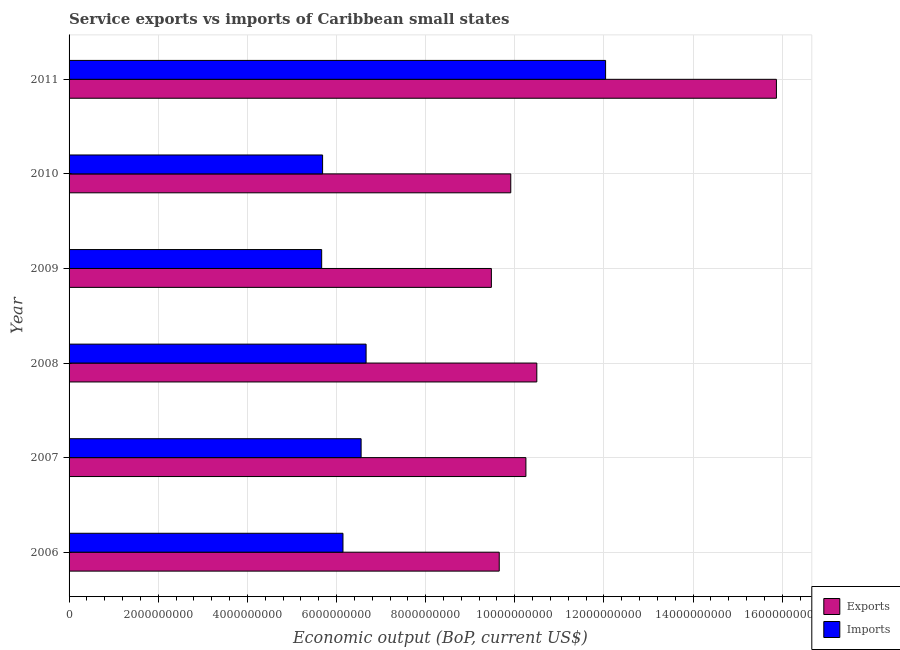How many bars are there on the 6th tick from the bottom?
Provide a succinct answer. 2. What is the label of the 3rd group of bars from the top?
Give a very brief answer. 2009. What is the amount of service imports in 2011?
Offer a very short reply. 1.20e+1. Across all years, what is the maximum amount of service imports?
Provide a succinct answer. 1.20e+1. Across all years, what is the minimum amount of service exports?
Give a very brief answer. 9.47e+09. What is the total amount of service exports in the graph?
Give a very brief answer. 6.56e+1. What is the difference between the amount of service exports in 2006 and that in 2008?
Keep it short and to the point. -8.43e+08. What is the difference between the amount of service exports in 2009 and the amount of service imports in 2007?
Ensure brevity in your answer.  2.92e+09. What is the average amount of service exports per year?
Provide a succinct answer. 1.09e+1. In the year 2006, what is the difference between the amount of service exports and amount of service imports?
Offer a very short reply. 3.51e+09. What is the ratio of the amount of service exports in 2009 to that in 2010?
Give a very brief answer. 0.96. Is the amount of service exports in 2010 less than that in 2011?
Your answer should be very brief. Yes. What is the difference between the highest and the second highest amount of service imports?
Keep it short and to the point. 5.37e+09. What is the difference between the highest and the lowest amount of service exports?
Your answer should be compact. 6.39e+09. In how many years, is the amount of service exports greater than the average amount of service exports taken over all years?
Your answer should be compact. 1. What does the 1st bar from the top in 2008 represents?
Offer a very short reply. Imports. What does the 1st bar from the bottom in 2010 represents?
Provide a short and direct response. Exports. Are all the bars in the graph horizontal?
Give a very brief answer. Yes. What is the difference between two consecutive major ticks on the X-axis?
Your response must be concise. 2.00e+09. Does the graph contain any zero values?
Keep it short and to the point. No. Does the graph contain grids?
Provide a succinct answer. Yes. How many legend labels are there?
Your response must be concise. 2. How are the legend labels stacked?
Your response must be concise. Vertical. What is the title of the graph?
Give a very brief answer. Service exports vs imports of Caribbean small states. Does "Agricultural land" appear as one of the legend labels in the graph?
Your answer should be compact. No. What is the label or title of the X-axis?
Keep it short and to the point. Economic output (BoP, current US$). What is the label or title of the Y-axis?
Offer a very short reply. Year. What is the Economic output (BoP, current US$) of Exports in 2006?
Give a very brief answer. 9.65e+09. What is the Economic output (BoP, current US$) in Imports in 2006?
Make the answer very short. 6.14e+09. What is the Economic output (BoP, current US$) in Exports in 2007?
Ensure brevity in your answer.  1.02e+1. What is the Economic output (BoP, current US$) of Imports in 2007?
Offer a terse response. 6.55e+09. What is the Economic output (BoP, current US$) of Exports in 2008?
Provide a succinct answer. 1.05e+1. What is the Economic output (BoP, current US$) of Imports in 2008?
Provide a succinct answer. 6.66e+09. What is the Economic output (BoP, current US$) of Exports in 2009?
Offer a terse response. 9.47e+09. What is the Economic output (BoP, current US$) in Imports in 2009?
Your answer should be compact. 5.67e+09. What is the Economic output (BoP, current US$) in Exports in 2010?
Provide a succinct answer. 9.91e+09. What is the Economic output (BoP, current US$) of Imports in 2010?
Your answer should be compact. 5.69e+09. What is the Economic output (BoP, current US$) in Exports in 2011?
Keep it short and to the point. 1.59e+1. What is the Economic output (BoP, current US$) in Imports in 2011?
Your answer should be compact. 1.20e+1. Across all years, what is the maximum Economic output (BoP, current US$) of Exports?
Offer a terse response. 1.59e+1. Across all years, what is the maximum Economic output (BoP, current US$) of Imports?
Offer a very short reply. 1.20e+1. Across all years, what is the minimum Economic output (BoP, current US$) of Exports?
Offer a very short reply. 9.47e+09. Across all years, what is the minimum Economic output (BoP, current US$) of Imports?
Your response must be concise. 5.67e+09. What is the total Economic output (BoP, current US$) of Exports in the graph?
Provide a succinct answer. 6.56e+1. What is the total Economic output (BoP, current US$) of Imports in the graph?
Keep it short and to the point. 4.28e+1. What is the difference between the Economic output (BoP, current US$) of Exports in 2006 and that in 2007?
Provide a short and direct response. -5.98e+08. What is the difference between the Economic output (BoP, current US$) of Imports in 2006 and that in 2007?
Your response must be concise. -4.07e+08. What is the difference between the Economic output (BoP, current US$) in Exports in 2006 and that in 2008?
Offer a terse response. -8.43e+08. What is the difference between the Economic output (BoP, current US$) in Imports in 2006 and that in 2008?
Provide a succinct answer. -5.19e+08. What is the difference between the Economic output (BoP, current US$) in Exports in 2006 and that in 2009?
Provide a short and direct response. 1.76e+08. What is the difference between the Economic output (BoP, current US$) of Imports in 2006 and that in 2009?
Make the answer very short. 4.78e+08. What is the difference between the Economic output (BoP, current US$) in Exports in 2006 and that in 2010?
Give a very brief answer. -2.59e+08. What is the difference between the Economic output (BoP, current US$) in Imports in 2006 and that in 2010?
Keep it short and to the point. 4.57e+08. What is the difference between the Economic output (BoP, current US$) in Exports in 2006 and that in 2011?
Provide a short and direct response. -6.22e+09. What is the difference between the Economic output (BoP, current US$) of Imports in 2006 and that in 2011?
Your answer should be compact. -5.89e+09. What is the difference between the Economic output (BoP, current US$) in Exports in 2007 and that in 2008?
Offer a very short reply. -2.45e+08. What is the difference between the Economic output (BoP, current US$) of Imports in 2007 and that in 2008?
Your response must be concise. -1.12e+08. What is the difference between the Economic output (BoP, current US$) of Exports in 2007 and that in 2009?
Give a very brief answer. 7.75e+08. What is the difference between the Economic output (BoP, current US$) in Imports in 2007 and that in 2009?
Offer a terse response. 8.85e+08. What is the difference between the Economic output (BoP, current US$) in Exports in 2007 and that in 2010?
Keep it short and to the point. 3.39e+08. What is the difference between the Economic output (BoP, current US$) in Imports in 2007 and that in 2010?
Provide a short and direct response. 8.64e+08. What is the difference between the Economic output (BoP, current US$) of Exports in 2007 and that in 2011?
Provide a short and direct response. -5.62e+09. What is the difference between the Economic output (BoP, current US$) of Imports in 2007 and that in 2011?
Ensure brevity in your answer.  -5.48e+09. What is the difference between the Economic output (BoP, current US$) in Exports in 2008 and that in 2009?
Your answer should be very brief. 1.02e+09. What is the difference between the Economic output (BoP, current US$) in Imports in 2008 and that in 2009?
Your answer should be very brief. 9.96e+08. What is the difference between the Economic output (BoP, current US$) in Exports in 2008 and that in 2010?
Provide a short and direct response. 5.84e+08. What is the difference between the Economic output (BoP, current US$) of Imports in 2008 and that in 2010?
Offer a terse response. 9.76e+08. What is the difference between the Economic output (BoP, current US$) of Exports in 2008 and that in 2011?
Ensure brevity in your answer.  -5.38e+09. What is the difference between the Economic output (BoP, current US$) of Imports in 2008 and that in 2011?
Provide a succinct answer. -5.37e+09. What is the difference between the Economic output (BoP, current US$) of Exports in 2009 and that in 2010?
Make the answer very short. -4.35e+08. What is the difference between the Economic output (BoP, current US$) of Imports in 2009 and that in 2010?
Offer a very short reply. -2.06e+07. What is the difference between the Economic output (BoP, current US$) in Exports in 2009 and that in 2011?
Provide a short and direct response. -6.39e+09. What is the difference between the Economic output (BoP, current US$) of Imports in 2009 and that in 2011?
Your answer should be very brief. -6.37e+09. What is the difference between the Economic output (BoP, current US$) of Exports in 2010 and that in 2011?
Keep it short and to the point. -5.96e+09. What is the difference between the Economic output (BoP, current US$) in Imports in 2010 and that in 2011?
Give a very brief answer. -6.35e+09. What is the difference between the Economic output (BoP, current US$) of Exports in 2006 and the Economic output (BoP, current US$) of Imports in 2007?
Give a very brief answer. 3.10e+09. What is the difference between the Economic output (BoP, current US$) of Exports in 2006 and the Economic output (BoP, current US$) of Imports in 2008?
Provide a succinct answer. 2.99e+09. What is the difference between the Economic output (BoP, current US$) in Exports in 2006 and the Economic output (BoP, current US$) in Imports in 2009?
Your answer should be very brief. 3.98e+09. What is the difference between the Economic output (BoP, current US$) of Exports in 2006 and the Economic output (BoP, current US$) of Imports in 2010?
Your answer should be compact. 3.96e+09. What is the difference between the Economic output (BoP, current US$) in Exports in 2006 and the Economic output (BoP, current US$) in Imports in 2011?
Offer a terse response. -2.39e+09. What is the difference between the Economic output (BoP, current US$) of Exports in 2007 and the Economic output (BoP, current US$) of Imports in 2008?
Provide a succinct answer. 3.59e+09. What is the difference between the Economic output (BoP, current US$) of Exports in 2007 and the Economic output (BoP, current US$) of Imports in 2009?
Your answer should be very brief. 4.58e+09. What is the difference between the Economic output (BoP, current US$) in Exports in 2007 and the Economic output (BoP, current US$) in Imports in 2010?
Provide a short and direct response. 4.56e+09. What is the difference between the Economic output (BoP, current US$) in Exports in 2007 and the Economic output (BoP, current US$) in Imports in 2011?
Your answer should be very brief. -1.79e+09. What is the difference between the Economic output (BoP, current US$) of Exports in 2008 and the Economic output (BoP, current US$) of Imports in 2009?
Your response must be concise. 4.83e+09. What is the difference between the Economic output (BoP, current US$) in Exports in 2008 and the Economic output (BoP, current US$) in Imports in 2010?
Provide a short and direct response. 4.81e+09. What is the difference between the Economic output (BoP, current US$) of Exports in 2008 and the Economic output (BoP, current US$) of Imports in 2011?
Your answer should be compact. -1.54e+09. What is the difference between the Economic output (BoP, current US$) in Exports in 2009 and the Economic output (BoP, current US$) in Imports in 2010?
Give a very brief answer. 3.79e+09. What is the difference between the Economic output (BoP, current US$) in Exports in 2009 and the Economic output (BoP, current US$) in Imports in 2011?
Your answer should be very brief. -2.56e+09. What is the difference between the Economic output (BoP, current US$) in Exports in 2010 and the Economic output (BoP, current US$) in Imports in 2011?
Give a very brief answer. -2.13e+09. What is the average Economic output (BoP, current US$) in Exports per year?
Offer a very short reply. 1.09e+1. What is the average Economic output (BoP, current US$) in Imports per year?
Your answer should be very brief. 7.13e+09. In the year 2006, what is the difference between the Economic output (BoP, current US$) in Exports and Economic output (BoP, current US$) in Imports?
Your response must be concise. 3.51e+09. In the year 2007, what is the difference between the Economic output (BoP, current US$) of Exports and Economic output (BoP, current US$) of Imports?
Offer a very short reply. 3.70e+09. In the year 2008, what is the difference between the Economic output (BoP, current US$) of Exports and Economic output (BoP, current US$) of Imports?
Ensure brevity in your answer.  3.83e+09. In the year 2009, what is the difference between the Economic output (BoP, current US$) of Exports and Economic output (BoP, current US$) of Imports?
Your answer should be compact. 3.81e+09. In the year 2010, what is the difference between the Economic output (BoP, current US$) of Exports and Economic output (BoP, current US$) of Imports?
Offer a very short reply. 4.22e+09. In the year 2011, what is the difference between the Economic output (BoP, current US$) of Exports and Economic output (BoP, current US$) of Imports?
Offer a very short reply. 3.83e+09. What is the ratio of the Economic output (BoP, current US$) of Exports in 2006 to that in 2007?
Provide a short and direct response. 0.94. What is the ratio of the Economic output (BoP, current US$) in Imports in 2006 to that in 2007?
Ensure brevity in your answer.  0.94. What is the ratio of the Economic output (BoP, current US$) in Exports in 2006 to that in 2008?
Offer a terse response. 0.92. What is the ratio of the Economic output (BoP, current US$) of Imports in 2006 to that in 2008?
Offer a very short reply. 0.92. What is the ratio of the Economic output (BoP, current US$) in Exports in 2006 to that in 2009?
Give a very brief answer. 1.02. What is the ratio of the Economic output (BoP, current US$) in Imports in 2006 to that in 2009?
Ensure brevity in your answer.  1.08. What is the ratio of the Economic output (BoP, current US$) in Exports in 2006 to that in 2010?
Give a very brief answer. 0.97. What is the ratio of the Economic output (BoP, current US$) of Imports in 2006 to that in 2010?
Offer a very short reply. 1.08. What is the ratio of the Economic output (BoP, current US$) of Exports in 2006 to that in 2011?
Provide a succinct answer. 0.61. What is the ratio of the Economic output (BoP, current US$) in Imports in 2006 to that in 2011?
Provide a succinct answer. 0.51. What is the ratio of the Economic output (BoP, current US$) of Exports in 2007 to that in 2008?
Give a very brief answer. 0.98. What is the ratio of the Economic output (BoP, current US$) in Imports in 2007 to that in 2008?
Your response must be concise. 0.98. What is the ratio of the Economic output (BoP, current US$) of Exports in 2007 to that in 2009?
Your answer should be very brief. 1.08. What is the ratio of the Economic output (BoP, current US$) in Imports in 2007 to that in 2009?
Provide a short and direct response. 1.16. What is the ratio of the Economic output (BoP, current US$) in Exports in 2007 to that in 2010?
Keep it short and to the point. 1.03. What is the ratio of the Economic output (BoP, current US$) in Imports in 2007 to that in 2010?
Offer a terse response. 1.15. What is the ratio of the Economic output (BoP, current US$) in Exports in 2007 to that in 2011?
Your answer should be compact. 0.65. What is the ratio of the Economic output (BoP, current US$) in Imports in 2007 to that in 2011?
Provide a short and direct response. 0.54. What is the ratio of the Economic output (BoP, current US$) of Exports in 2008 to that in 2009?
Provide a succinct answer. 1.11. What is the ratio of the Economic output (BoP, current US$) of Imports in 2008 to that in 2009?
Keep it short and to the point. 1.18. What is the ratio of the Economic output (BoP, current US$) in Exports in 2008 to that in 2010?
Your answer should be very brief. 1.06. What is the ratio of the Economic output (BoP, current US$) in Imports in 2008 to that in 2010?
Ensure brevity in your answer.  1.17. What is the ratio of the Economic output (BoP, current US$) of Exports in 2008 to that in 2011?
Your response must be concise. 0.66. What is the ratio of the Economic output (BoP, current US$) of Imports in 2008 to that in 2011?
Give a very brief answer. 0.55. What is the ratio of the Economic output (BoP, current US$) of Exports in 2009 to that in 2010?
Provide a succinct answer. 0.96. What is the ratio of the Economic output (BoP, current US$) of Exports in 2009 to that in 2011?
Offer a terse response. 0.6. What is the ratio of the Economic output (BoP, current US$) of Imports in 2009 to that in 2011?
Make the answer very short. 0.47. What is the ratio of the Economic output (BoP, current US$) in Exports in 2010 to that in 2011?
Keep it short and to the point. 0.62. What is the ratio of the Economic output (BoP, current US$) in Imports in 2010 to that in 2011?
Ensure brevity in your answer.  0.47. What is the difference between the highest and the second highest Economic output (BoP, current US$) of Exports?
Make the answer very short. 5.38e+09. What is the difference between the highest and the second highest Economic output (BoP, current US$) of Imports?
Your response must be concise. 5.37e+09. What is the difference between the highest and the lowest Economic output (BoP, current US$) of Exports?
Make the answer very short. 6.39e+09. What is the difference between the highest and the lowest Economic output (BoP, current US$) in Imports?
Your response must be concise. 6.37e+09. 